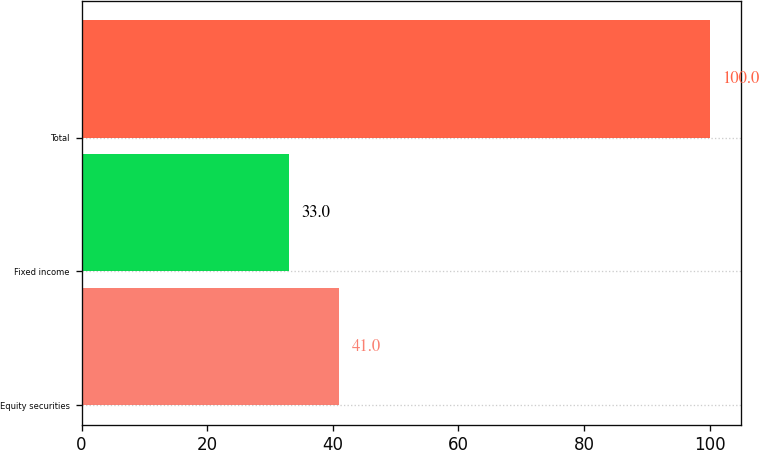<chart> <loc_0><loc_0><loc_500><loc_500><bar_chart><fcel>Equity securities<fcel>Fixed income<fcel>Total<nl><fcel>41<fcel>33<fcel>100<nl></chart> 